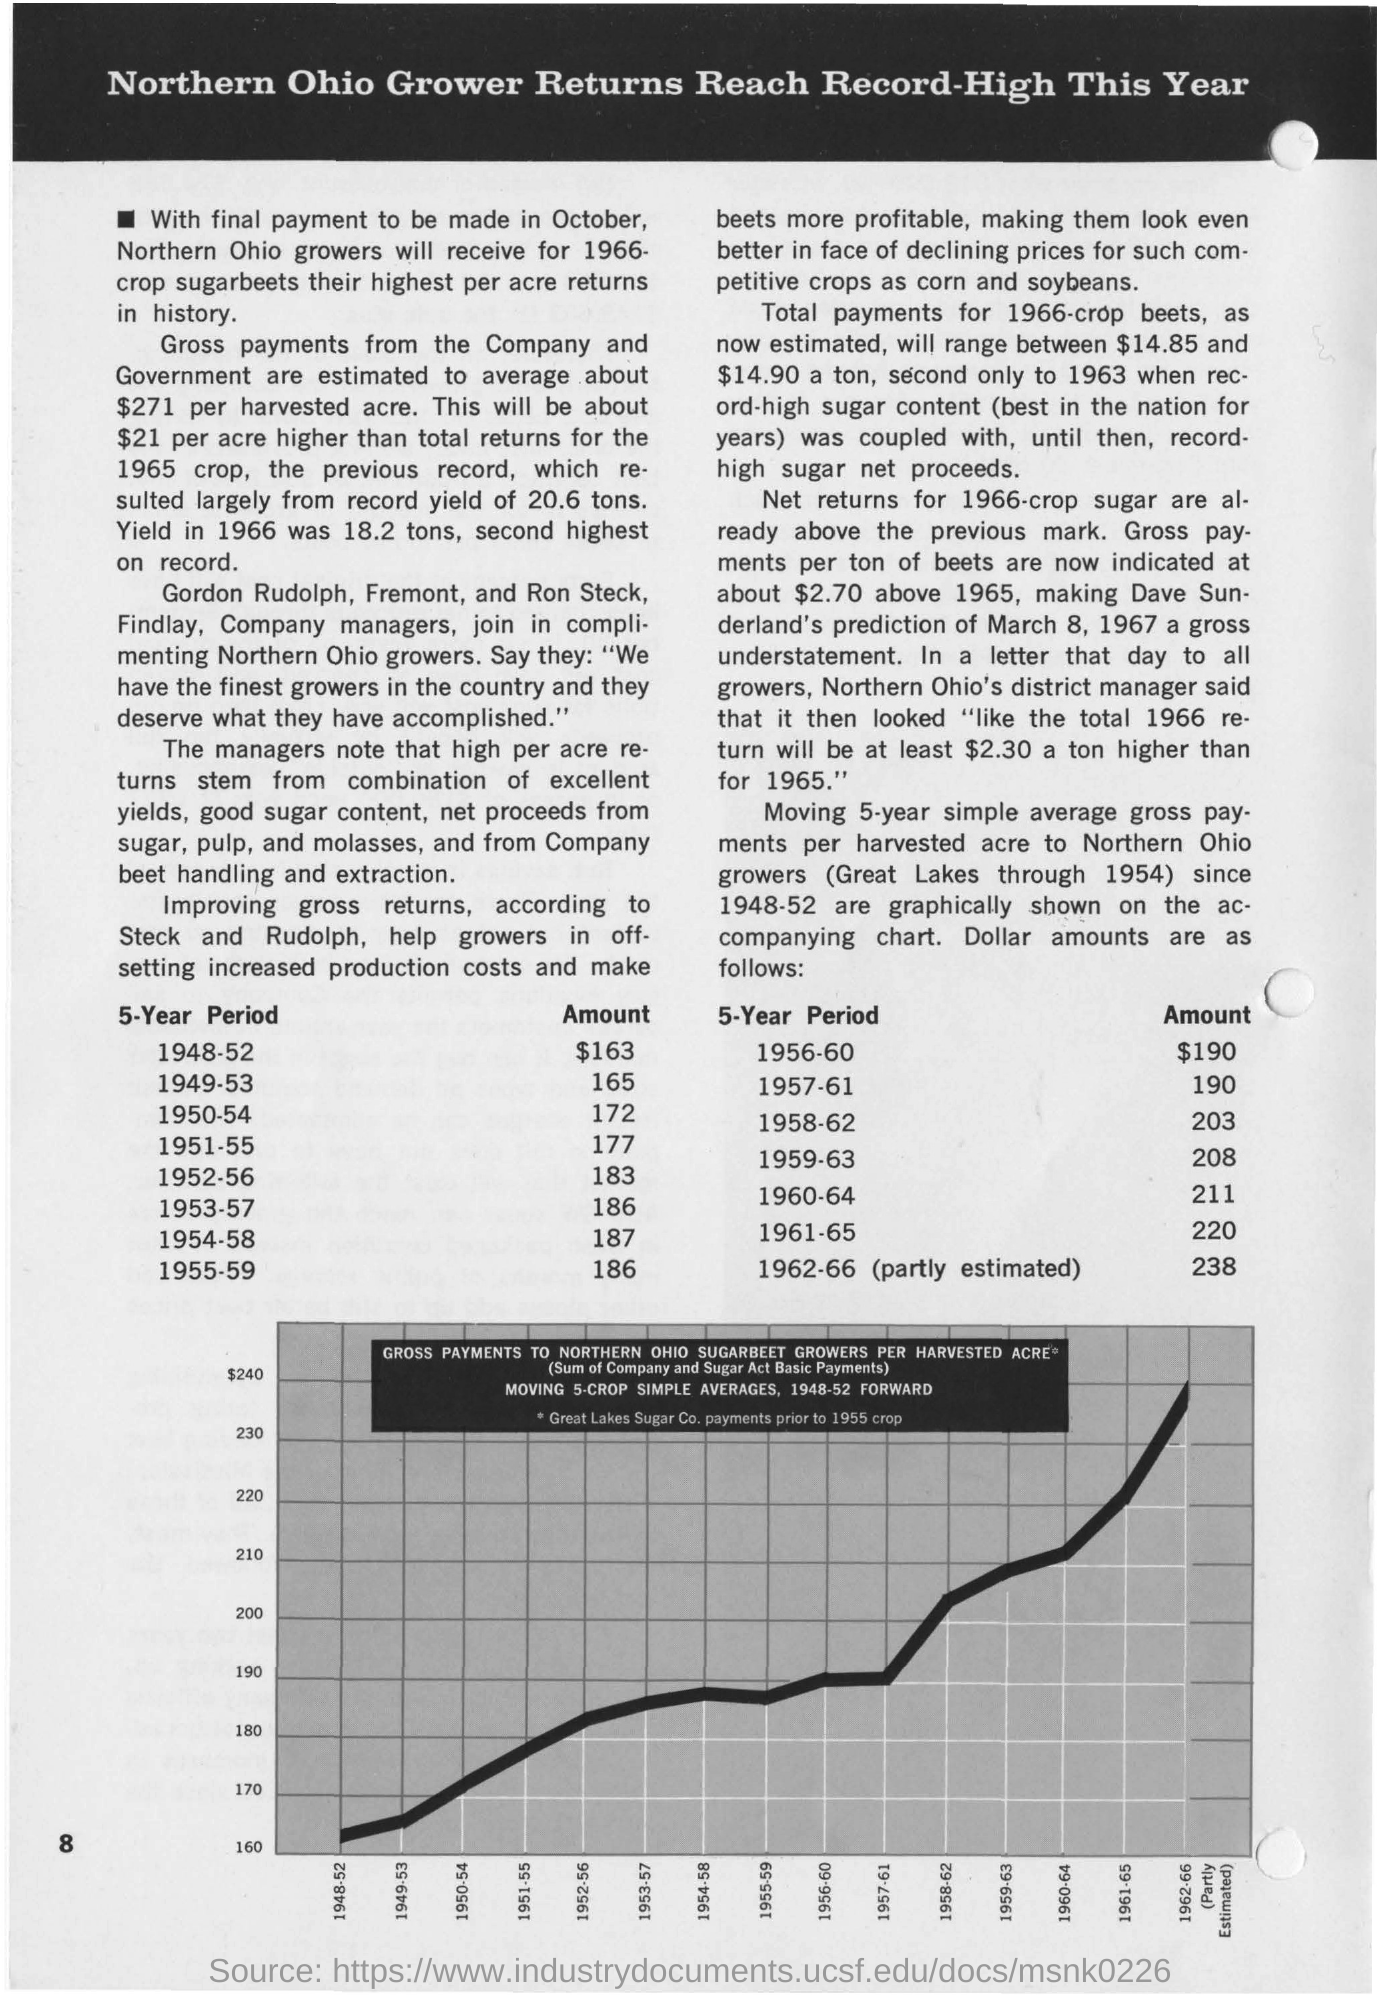Give some essential details in this illustration. The amount on the 5-year period from 1949 to 1953 was 165. The page number on this document is 8. In the five-year period from 1948 to 1952, the amount was $163. The amount on the 5-year period from 1957 to 1961 was 190. The amount for the 5-year period from 1956 to 1960 was $190. 